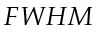<formula> <loc_0><loc_0><loc_500><loc_500>F W H M</formula> 